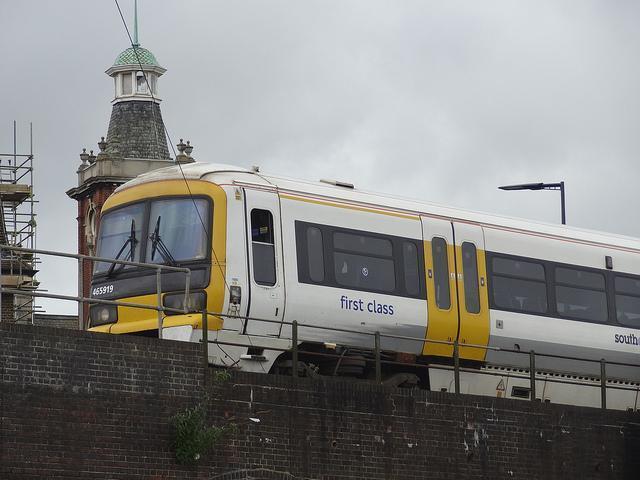How many people are not in the bus?
Give a very brief answer. 0. How many people are these?
Give a very brief answer. 0. 